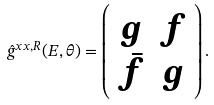<formula> <loc_0><loc_0><loc_500><loc_500>\hat { g } ^ { x x , R } ( E , \theta ) = \left ( \begin{array} { c c } g & f \\ \bar { f } & g \end{array} \right ) .</formula> 